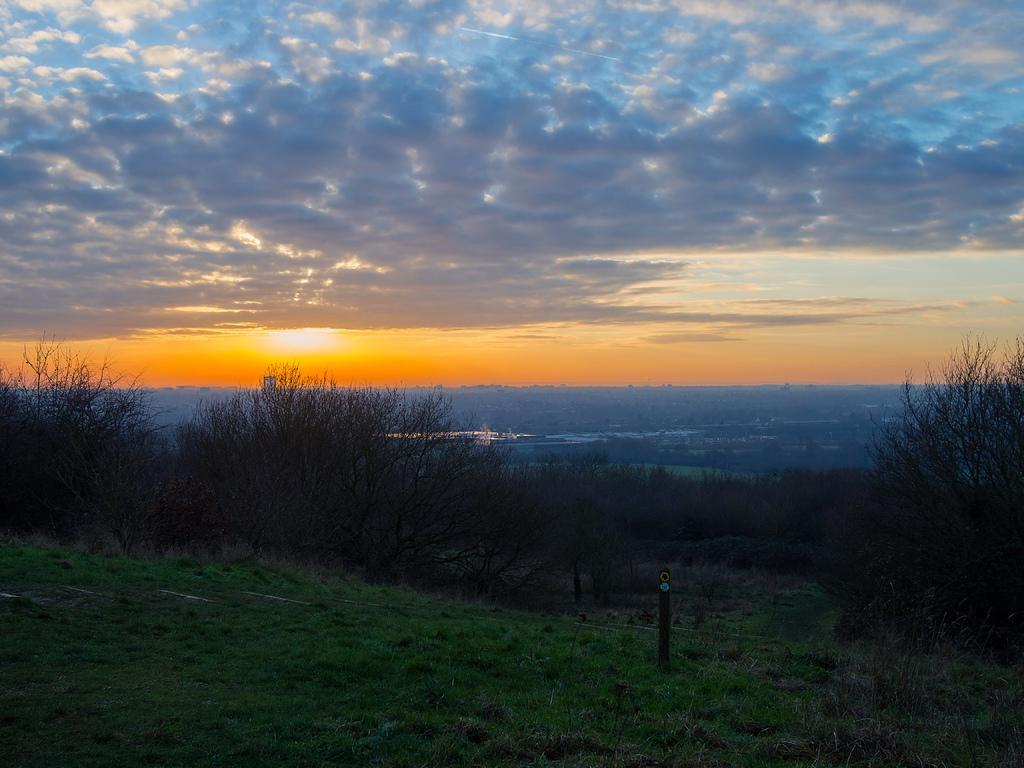Describe this image in one or two sentences. At the bottom of the image there is grass. There is a pole. There are trees. In the background of the image there is sky. There is sun. There are clouds. 